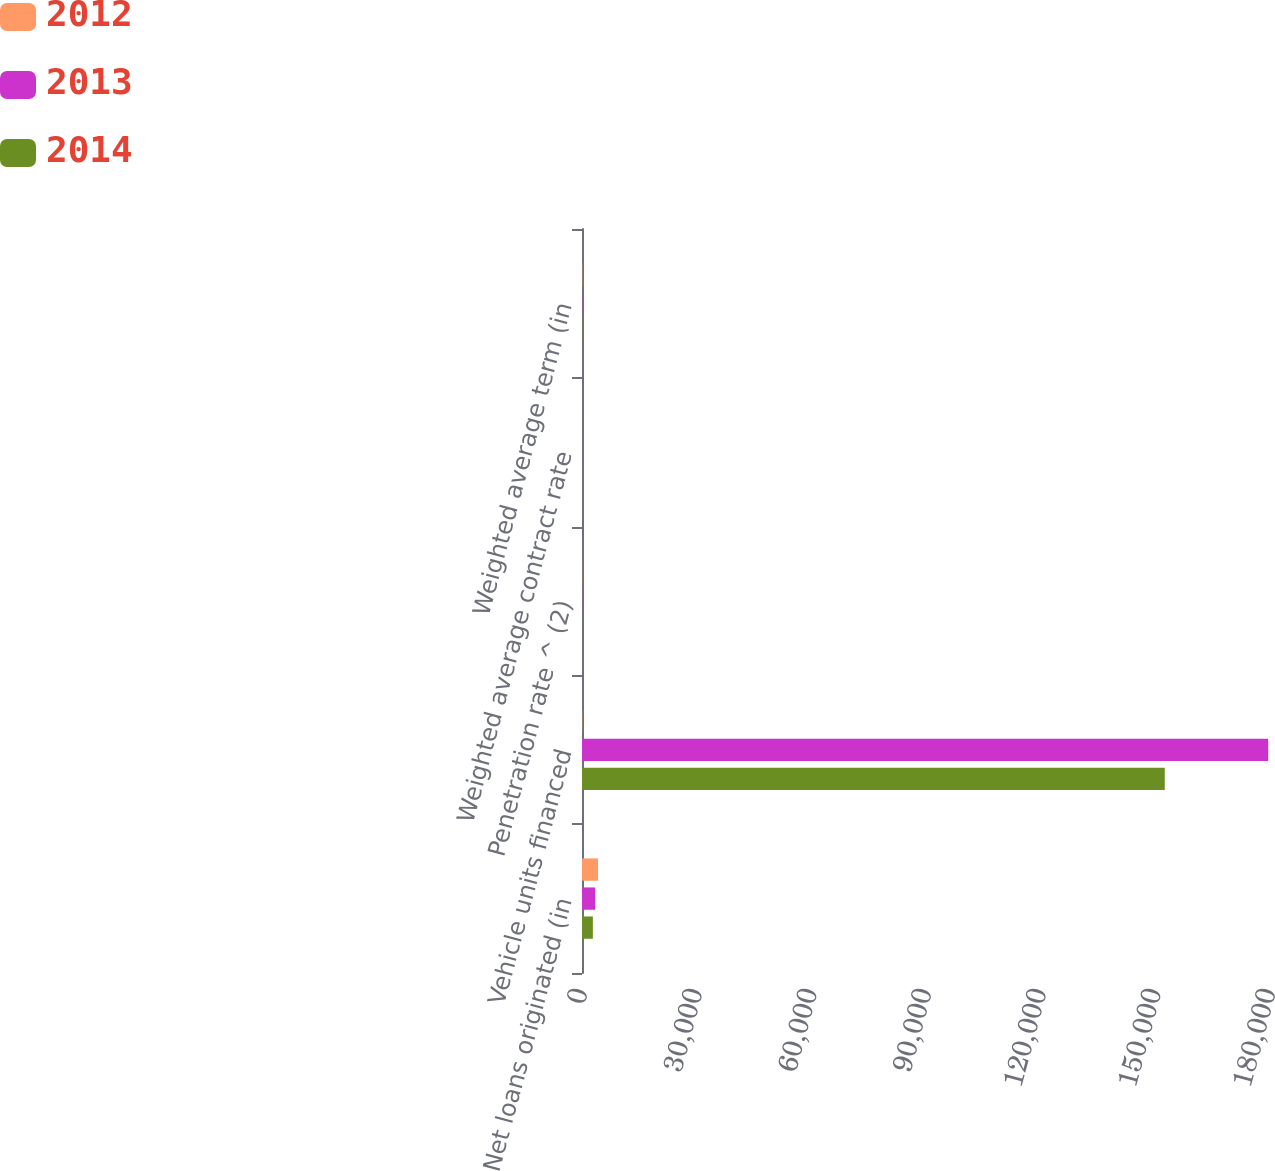Convert chart. <chart><loc_0><loc_0><loc_500><loc_500><stacked_bar_chart><ecel><fcel>Net loans originated (in<fcel>Vehicle units financed<fcel>Penetration rate ^ (2)<fcel>Weighted average contract rate<fcel>Weighted average term (in<nl><fcel>2012<fcel>4183.9<fcel>65.35<fcel>40.9<fcel>7<fcel>65.4<nl><fcel>2013<fcel>3445.3<fcel>179525<fcel>39.4<fcel>7.9<fcel>65.9<nl><fcel>2014<fcel>2842.9<fcel>152468<fcel>36.7<fcel>8.8<fcel>65.3<nl></chart> 